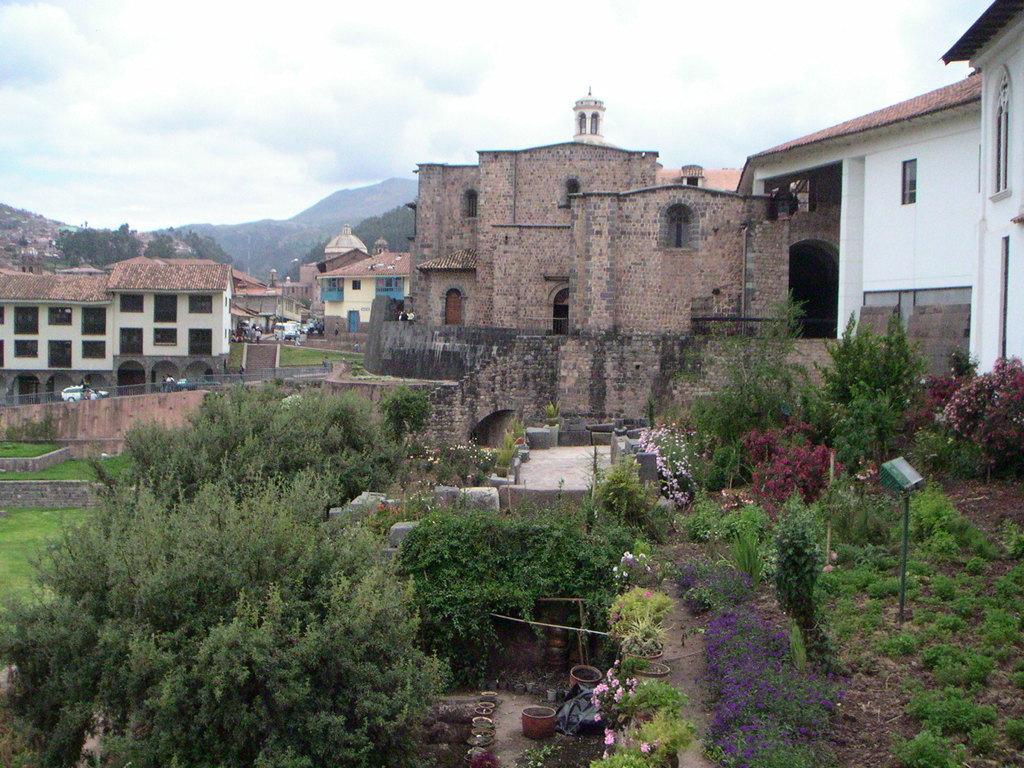How would you summarize this image in a sentence or two? In this image in the center there are trees, there is a pole and there's grass on the ground. In the background there are buildings, trees and mountains and the sky is cloudy. 